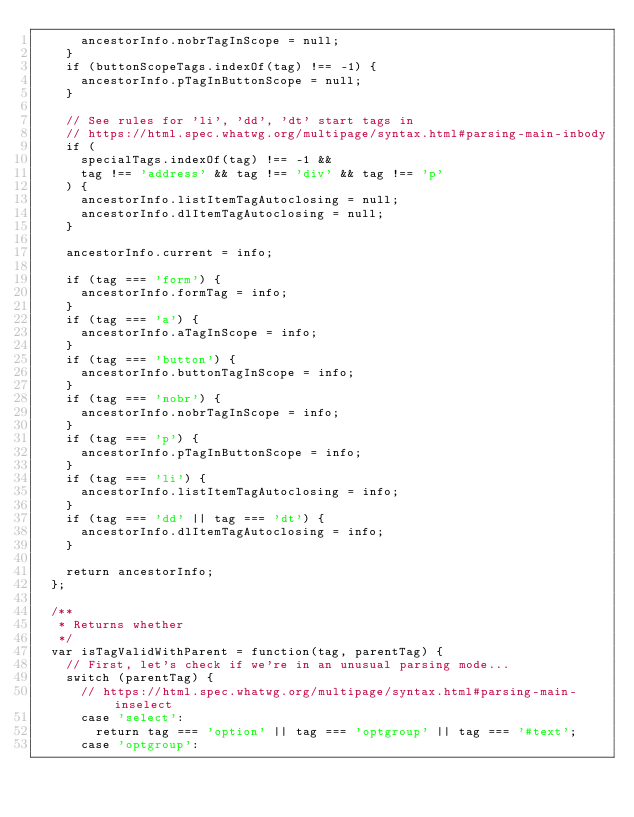Convert code to text. <code><loc_0><loc_0><loc_500><loc_500><_JavaScript_>      ancestorInfo.nobrTagInScope = null;
    }
    if (buttonScopeTags.indexOf(tag) !== -1) {
      ancestorInfo.pTagInButtonScope = null;
    }

    // See rules for 'li', 'dd', 'dt' start tags in
    // https://html.spec.whatwg.org/multipage/syntax.html#parsing-main-inbody
    if (
      specialTags.indexOf(tag) !== -1 &&
      tag !== 'address' && tag !== 'div' && tag !== 'p'
    ) {
      ancestorInfo.listItemTagAutoclosing = null;
      ancestorInfo.dlItemTagAutoclosing = null;
    }

    ancestorInfo.current = info;

    if (tag === 'form') {
      ancestorInfo.formTag = info;
    }
    if (tag === 'a') {
      ancestorInfo.aTagInScope = info;
    }
    if (tag === 'button') {
      ancestorInfo.buttonTagInScope = info;
    }
    if (tag === 'nobr') {
      ancestorInfo.nobrTagInScope = info;
    }
    if (tag === 'p') {
      ancestorInfo.pTagInButtonScope = info;
    }
    if (tag === 'li') {
      ancestorInfo.listItemTagAutoclosing = info;
    }
    if (tag === 'dd' || tag === 'dt') {
      ancestorInfo.dlItemTagAutoclosing = info;
    }

    return ancestorInfo;
  };

  /**
   * Returns whether
   */
  var isTagValidWithParent = function(tag, parentTag) {
    // First, let's check if we're in an unusual parsing mode...
    switch (parentTag) {
      // https://html.spec.whatwg.org/multipage/syntax.html#parsing-main-inselect
      case 'select':
        return tag === 'option' || tag === 'optgroup' || tag === '#text';
      case 'optgroup':</code> 